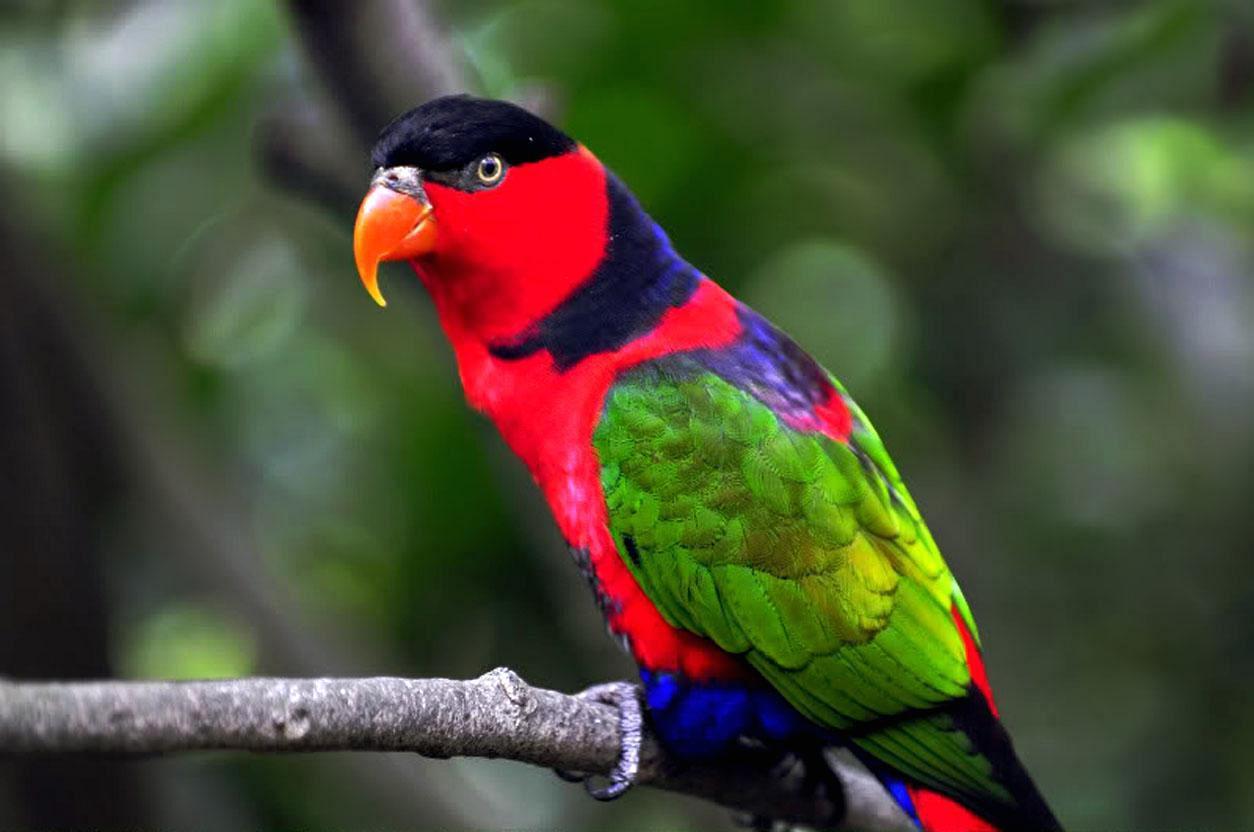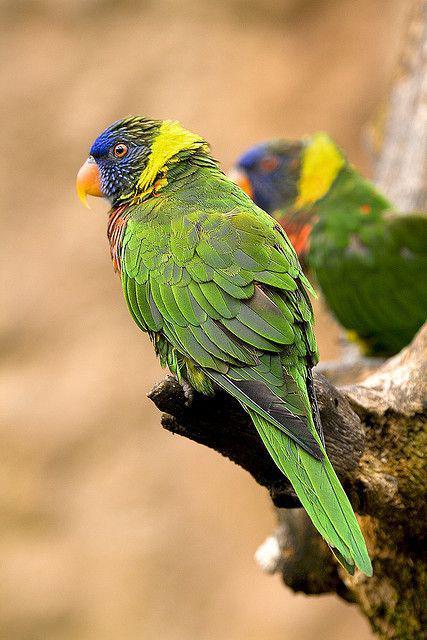The first image is the image on the left, the second image is the image on the right. Considering the images on both sides, is "There are a total of three birds" valid? Answer yes or no. Yes. 